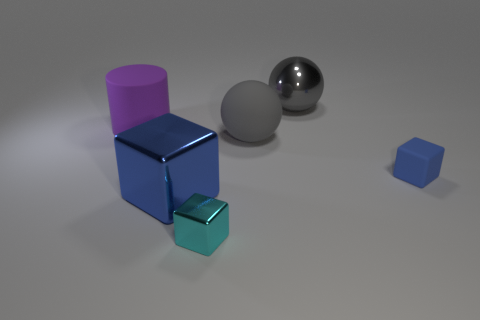Does the small cyan object have the same shape as the blue thing to the left of the small cyan metal cube? While the small cyan object appears to be a cube similar to the larger blue object, the perspective may slightly distort their apparent shapes. However, given the visual information, it is reasonable to say that both objects share a cube shape with six equal square faces, sharp edges, and vertices at right angles. 